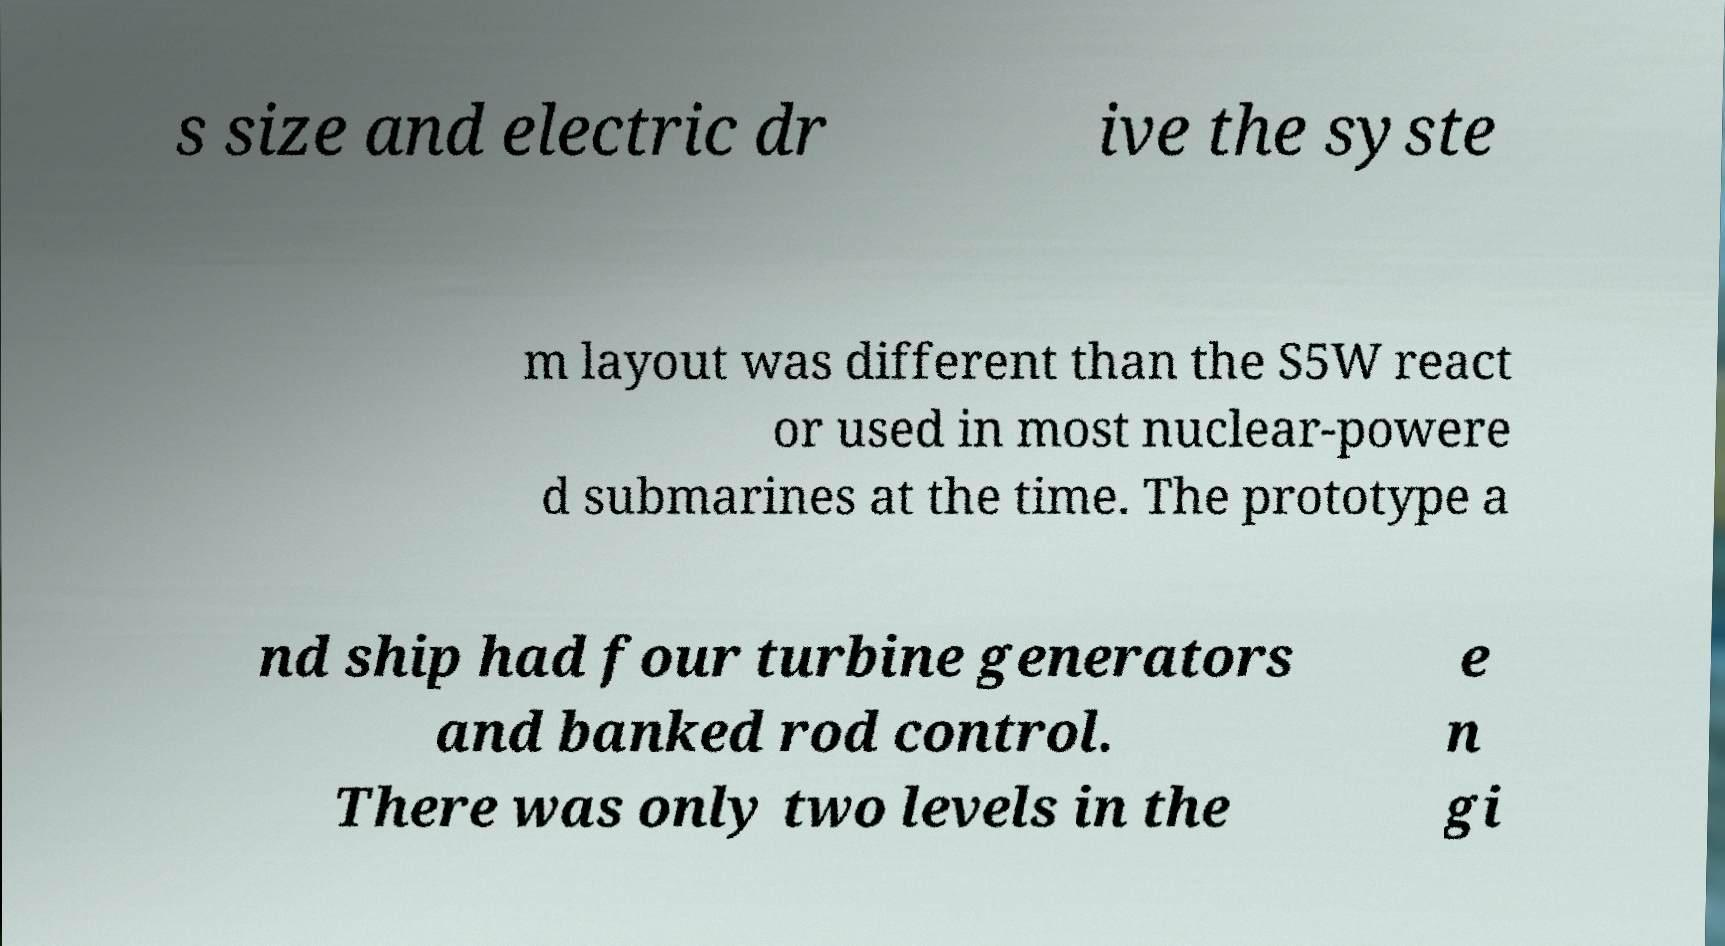Please read and relay the text visible in this image. What does it say? s size and electric dr ive the syste m layout was different than the S5W react or used in most nuclear-powere d submarines at the time. The prototype a nd ship had four turbine generators and banked rod control. There was only two levels in the e n gi 